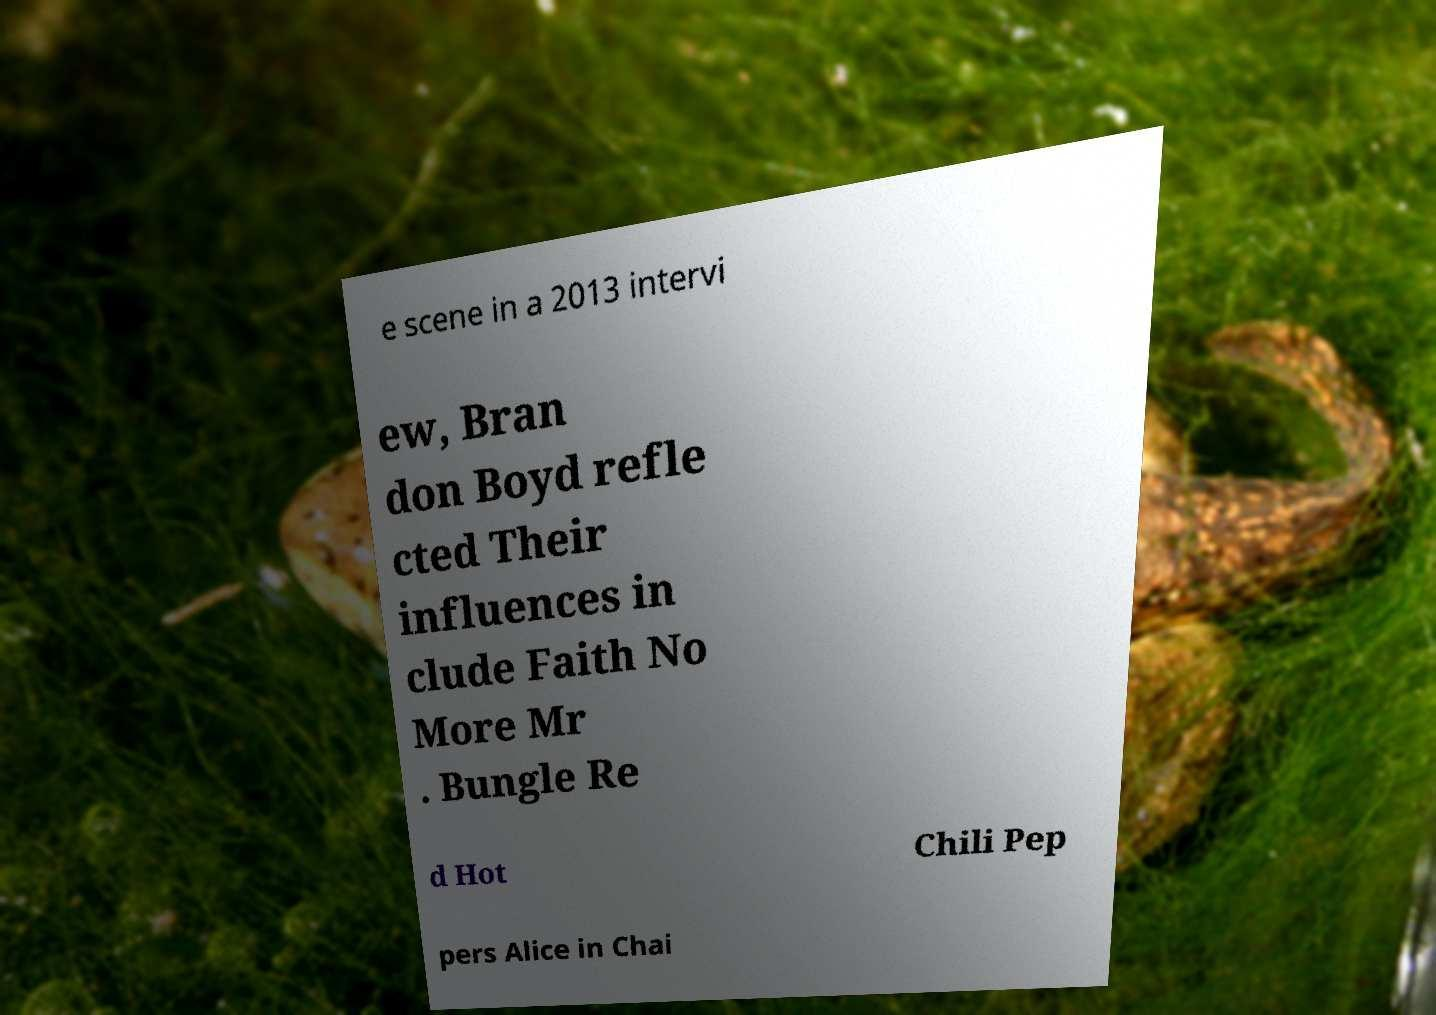I need the written content from this picture converted into text. Can you do that? e scene in a 2013 intervi ew, Bran don Boyd refle cted Their influences in clude Faith No More Mr . Bungle Re d Hot Chili Pep pers Alice in Chai 